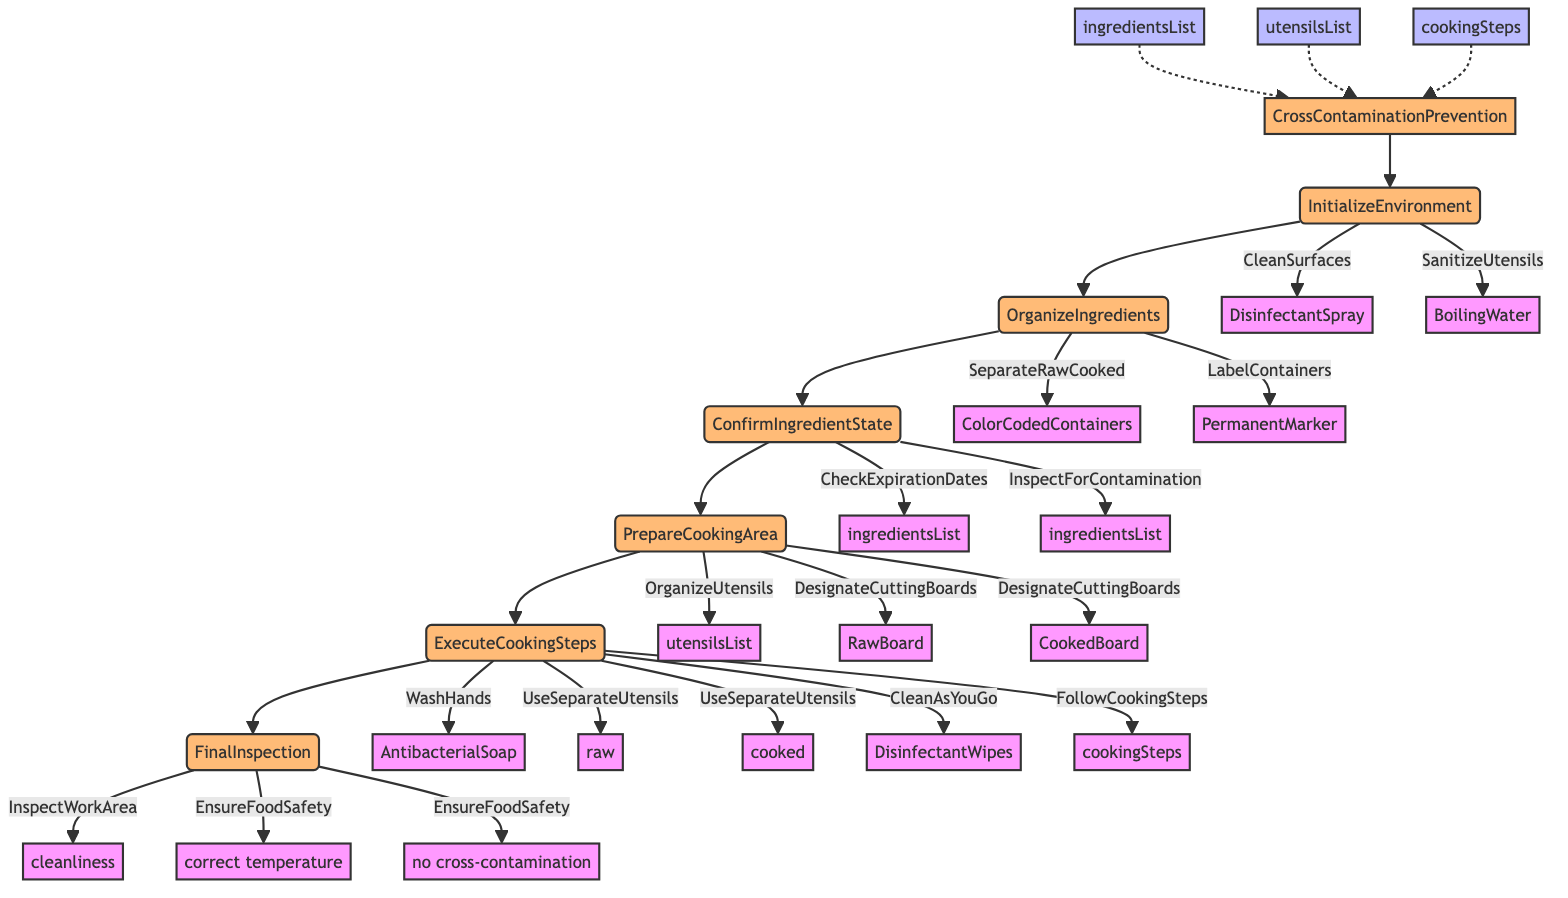What is the first step in the function? The first step in the function is labeled as "InitializeEnvironment." According to the flowchart, it directly follows the function's name and is the first action to be executed.
Answer: InitializeEnvironment How many main steps are there in the function? The flowchart has six main steps that follow the "CrossContaminationPrevention" function, which are InitializeEnvironment, OrganizeIngredients, ConfirmIngredientState, PrepareCookingArea, ExecuteCookingSteps, and FinalInspection.
Answer: 6 What tool is used for cleaning surfaces? In the "InitializeEnvironment" step, the action "CleanSurfaces" is associated with the tool "DisinfectantSpray" as a necessary measure for an initial cleaning of surfaces.
Answer: DisinfectantSpray What is the action taken to confirm ingredient safety? During the step "ConfirmIngredientState," the actions taken include "CheckExpirationDates" and "InspectForContamination." These actions ensure the ingredients are safe to use before cooking.
Answer: CheckExpirationDates and InspectForContamination Which tools are designated for cutting boards in the cooking area? In the "PrepareCookingArea" step, there are two designated cutting boards: "RawBoard" and "CookedBoard." These are important for preventing cross-contamination between raw and cooked ingredients.
Answer: RawBoard and CookedBoard In which step do you wash your hands? The action "WashHands" occurs in the "ExecuteCookingSteps" stage, specifically before handling raw ingredients, emphasizing the importance of hygiene while cooking.
Answer: ExecuteCookingSteps What is the purpose of using color-coded containers? Using color-coded containers serves to "SeparateRawCooked," which helps to visually distinguish between raw and cooked ingredients, thus preventing cross-contamination.
Answer: SeparateRawCooked What final actions are taken in the "FinalInspection" step? During the "FinalInspection" step, two actions are taken: "InspectWorkArea" and "EnsureFoodSafety." These help to confirm that the cooking area meets safety standards and no cross-contamination has occurred.
Answer: InspectWorkArea and EnsureFoodSafety 